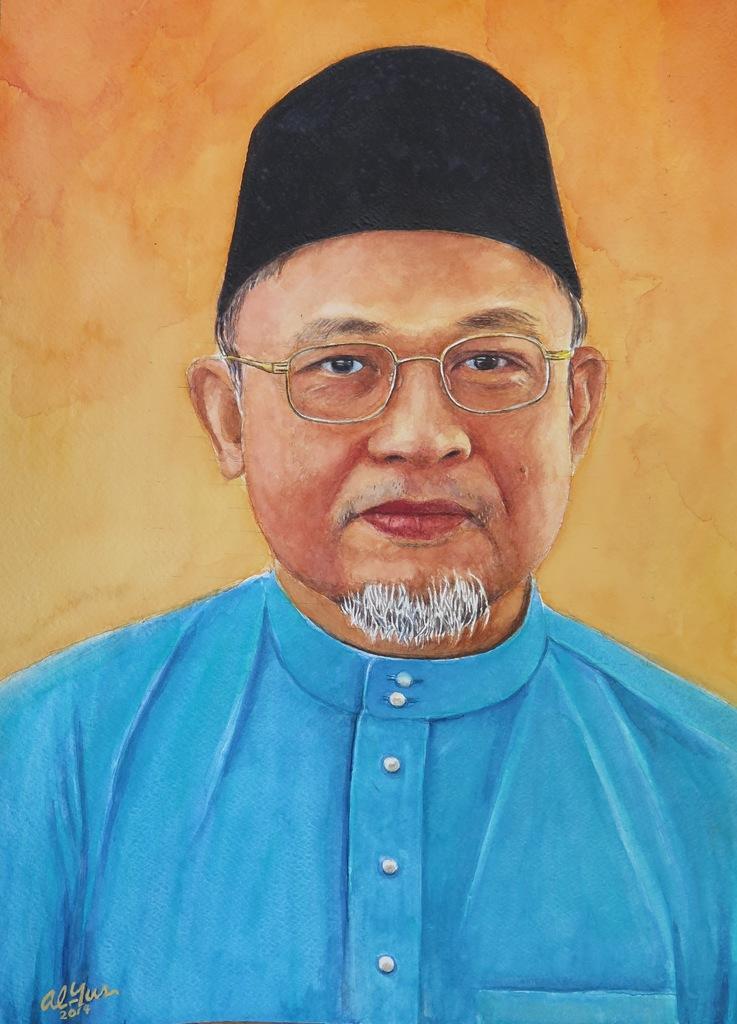Can you describe this image briefly? In this image there is a painting of a person at the bottom of the image there is some text. 